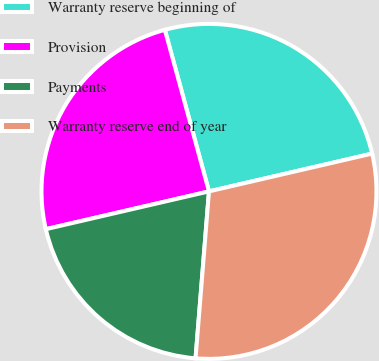Convert chart to OTSL. <chart><loc_0><loc_0><loc_500><loc_500><pie_chart><fcel>Warranty reserve beginning of<fcel>Provision<fcel>Payments<fcel>Warranty reserve end of year<nl><fcel>25.62%<fcel>24.38%<fcel>20.1%<fcel>29.9%<nl></chart> 